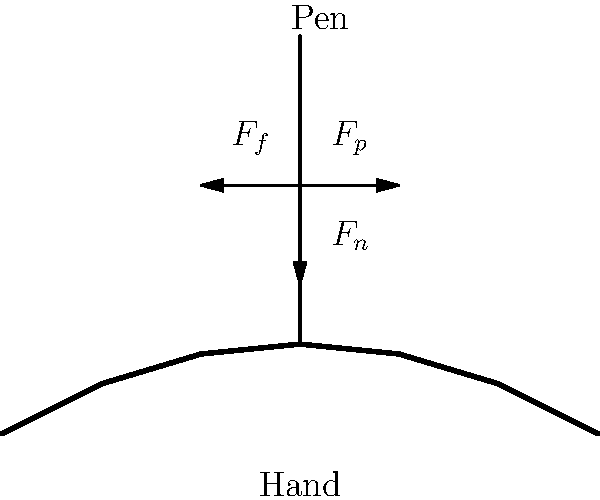In the context of medieval manuscript writing, consider the biomechanical forces acting on a monk's hand during repetitive writing. Which force is primarily responsible for the friction between the pen and the writing surface, and how does it relate to the normal force? To understand the biomechanical forces acting on a monk's hand during manuscript writing, we need to consider the following steps:

1. Identify the forces:
   - $F_p$: The pushing force exerted by the monk's hand on the pen
   - $F_n$: The normal force from the writing surface
   - $F_f$: The friction force between the pen and the writing surface

2. Understand the relationship between normal force and friction:
   The friction force $F_f$ is directly proportional to the normal force $F_n$. This relationship is expressed as:

   $$F_f = \mu F_n$$

   where $\mu$ is the coefficient of friction between the pen and the writing surface.

3. Analyze the role of the pushing force:
   The pushing force $F_p$ applied by the monk's hand is responsible for creating the normal force $F_n$. As the monk presses down on the pen, an equal and opposite force (the normal force) is exerted upward by the writing surface.

4. Consider the balance of forces:
   For the pen to move across the surface while writing, the pushing force must overcome the friction force. However, the friction force is necessary for the pen to leave marks on the writing surface.

5. Relate to the question:
   The friction force $F_f$ is primarily responsible for the interaction between the pen and the writing surface. It is directly related to the normal force $F_n$ through the coefficient of friction $\mu$.

Therefore, the friction force $F_f$ is the key force responsible for the friction between the pen and the writing surface, and it is directly proportional to the normal force $F_n$.
Answer: Friction force; directly proportional to normal force 